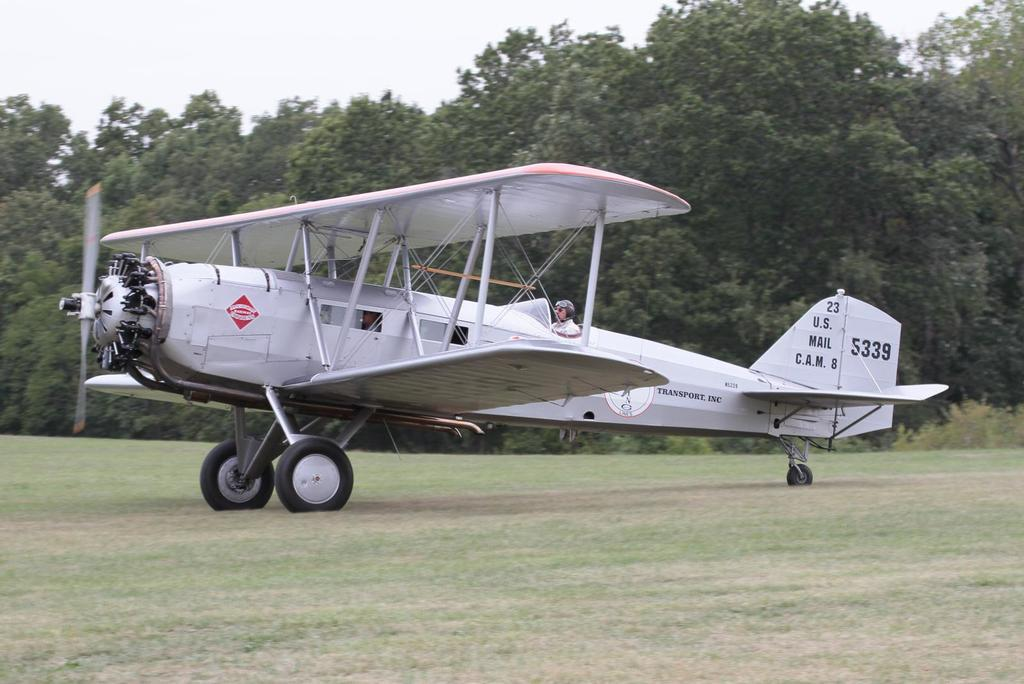What is the main subject of the image? The main subject of the image is an airplane. Can you describe the person inside the airplane? Unfortunately, the person inside the airplane cannot be described in detail as they are not visible in the image. What color is the airplane? The airplane is white in color. What can be seen in the background of the image? There are trees visible in the background. What is the color of the sky in the image? The sky is white in color. What type of joke is the person telling inside the airplane? There is no person visible inside the airplane, and therefore no joke can be observed. What is the temper of the airplane in the image? The airplane is an inanimate object and does not have a temper. 